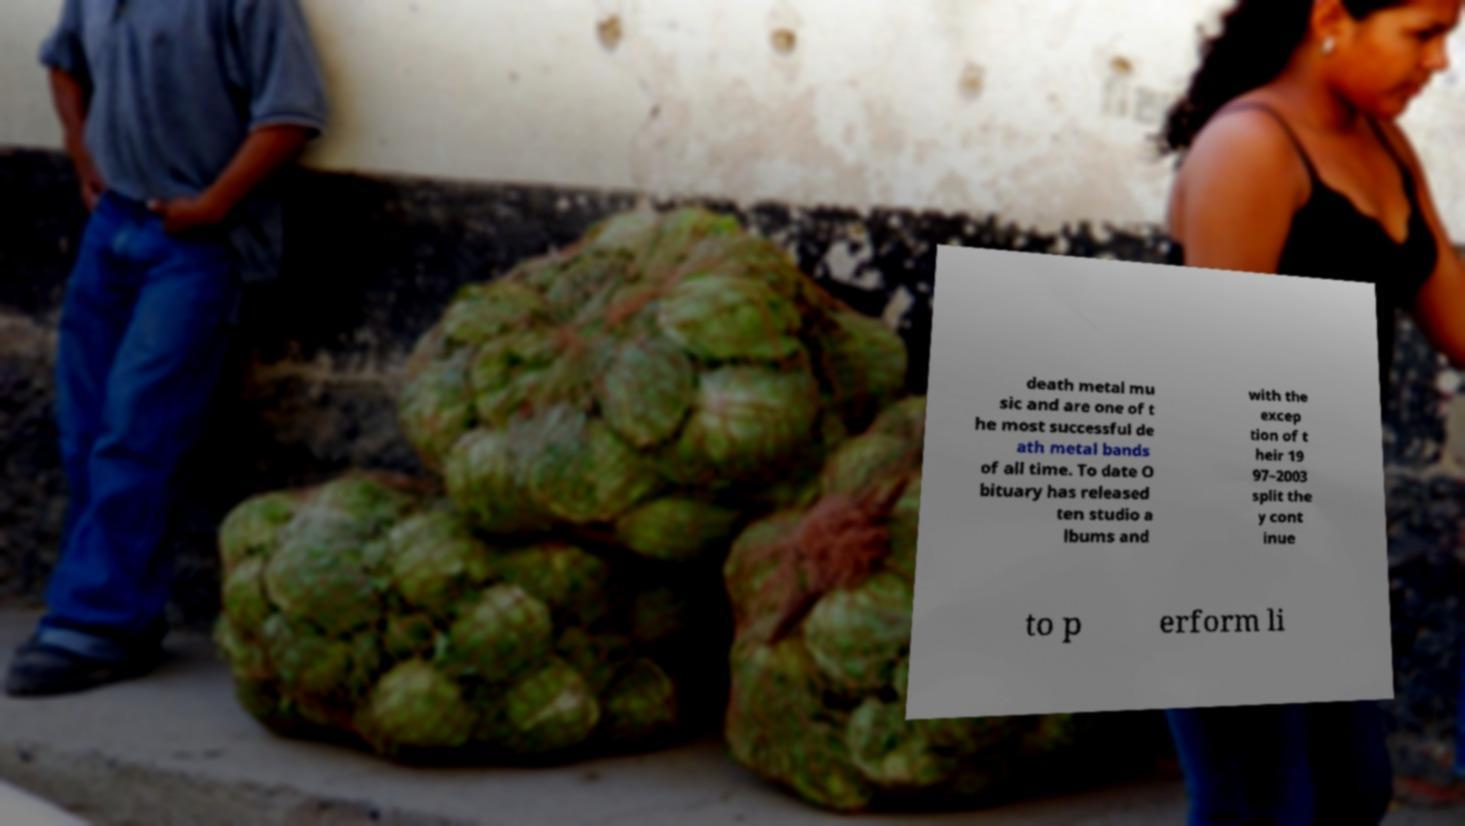There's text embedded in this image that I need extracted. Can you transcribe it verbatim? death metal mu sic and are one of t he most successful de ath metal bands of all time. To date O bituary has released ten studio a lbums and with the excep tion of t heir 19 97–2003 split the y cont inue to p erform li 